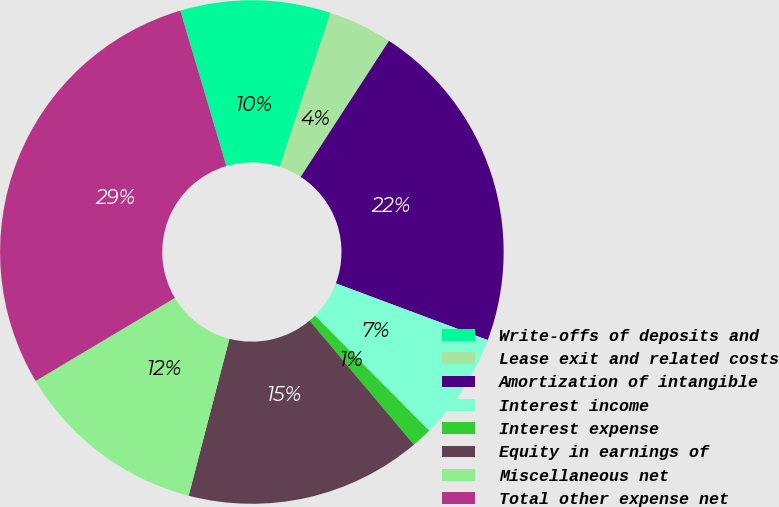Convert chart to OTSL. <chart><loc_0><loc_0><loc_500><loc_500><pie_chart><fcel>Write-offs of deposits and<fcel>Lease exit and related costs<fcel>Amortization of intangible<fcel>Interest income<fcel>Interest expense<fcel>Equity in earnings of<fcel>Miscellaneous net<fcel>Total other expense net<nl><fcel>9.64%<fcel>4.11%<fcel>21.52%<fcel>6.87%<fcel>1.31%<fcel>15.17%<fcel>12.4%<fcel>28.97%<nl></chart> 